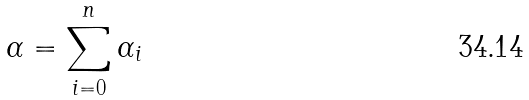<formula> <loc_0><loc_0><loc_500><loc_500>\alpha = \sum _ { i = 0 } ^ { n } \alpha _ { i }</formula> 